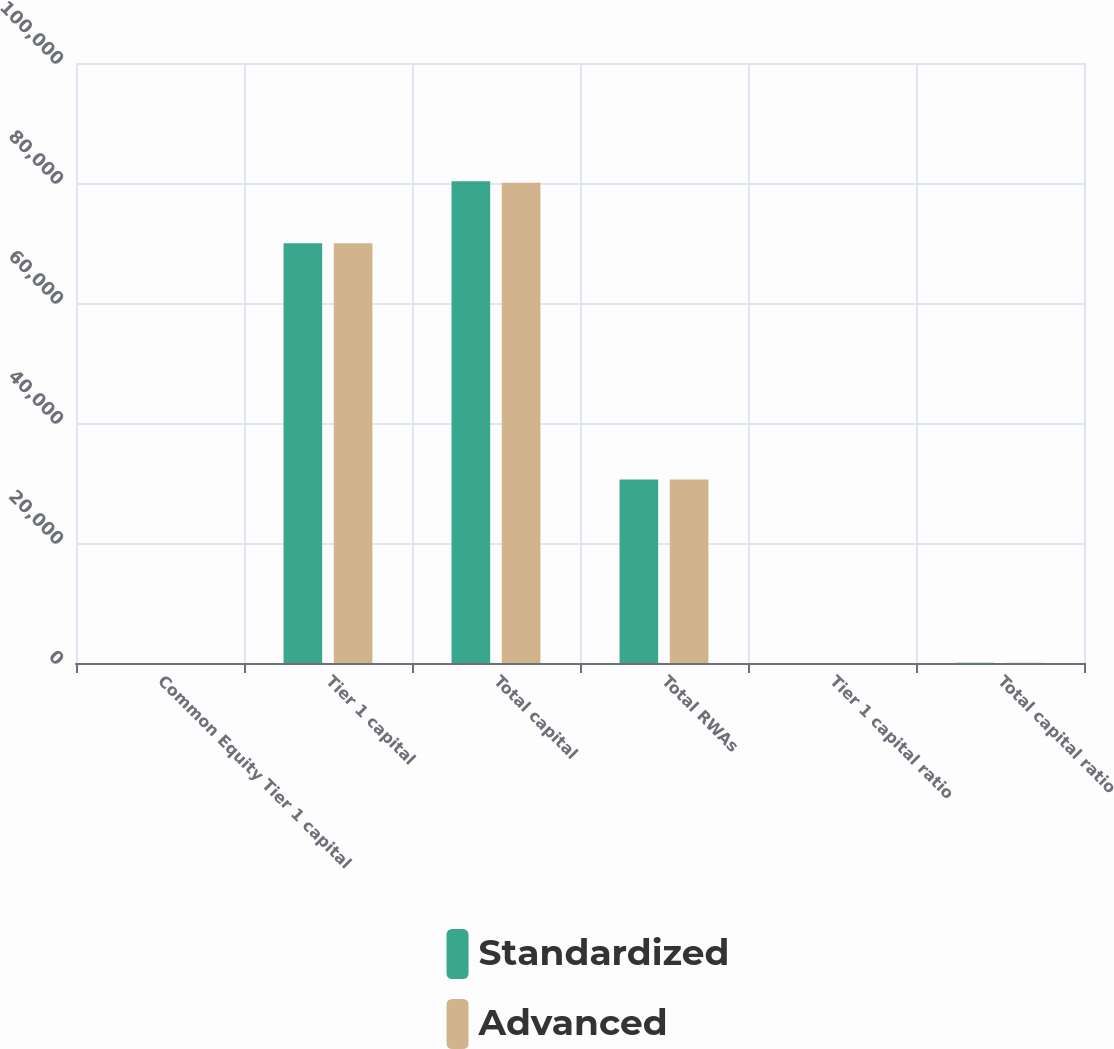Convert chart. <chart><loc_0><loc_0><loc_500><loc_500><stacked_bar_chart><ecel><fcel>Common Equity Tier 1 capital<fcel>Tier 1 capital<fcel>Total capital<fcel>Total RWAs<fcel>Tier 1 capital ratio<fcel>Total capital ratio<nl><fcel>Standardized<fcel>16.5<fcel>69938<fcel>80275<fcel>30578.5<fcel>18.9<fcel>21.7<nl><fcel>Advanced<fcel>17.5<fcel>69938<fcel>80046<fcel>30578.5<fcel>20<fcel>22.9<nl></chart> 